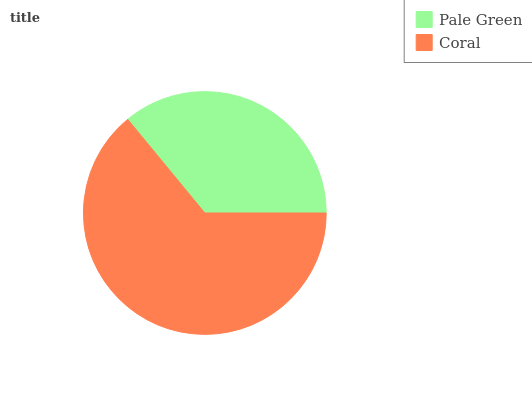Is Pale Green the minimum?
Answer yes or no. Yes. Is Coral the maximum?
Answer yes or no. Yes. Is Coral the minimum?
Answer yes or no. No. Is Coral greater than Pale Green?
Answer yes or no. Yes. Is Pale Green less than Coral?
Answer yes or no. Yes. Is Pale Green greater than Coral?
Answer yes or no. No. Is Coral less than Pale Green?
Answer yes or no. No. Is Coral the high median?
Answer yes or no. Yes. Is Pale Green the low median?
Answer yes or no. Yes. Is Pale Green the high median?
Answer yes or no. No. Is Coral the low median?
Answer yes or no. No. 